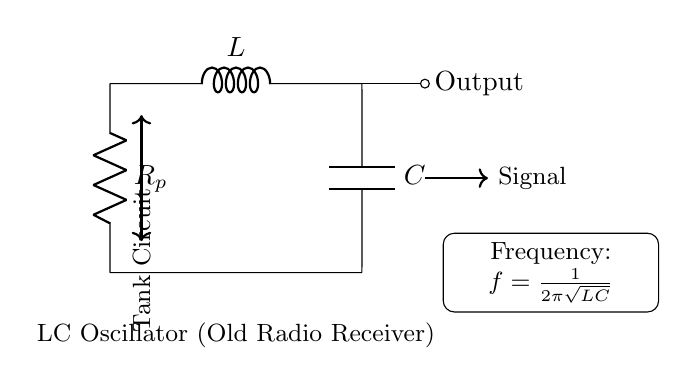What are the components used in the circuit? The circuit contains three components: an inductor (L), a capacitor (C), and a resistor (R_p). These can be identified by their labels in the diagram.
Answer: L, C, R_p What is the function of the tank circuit? The tank circuit, formed by the inductor and capacitor in parallel, is responsible for the oscillation, allowing the circuit to store and exchange energy between the inductor and capacitor, creating an oscillating signal.
Answer: Oscillation What does the output denote in the circuit diagram? The output is the point from which the signal can be extracted from the tank circuit, typically connected to the next stage of a radio receiver. It denotes the signal generated by the oscillation of the circuit.
Answer: Signal What is the formula for frequency provided in the circuit? The formula displayed indicates that frequency (f) is calculated using the inductance (L) and capacitance (C) with the equation f = 1/(2π√(LC)), which tells us how the circuit oscillates at certain frequencies depending on these values.
Answer: f = 1/(2π√(LC)) What type of circuit is represented here? This is an LC oscillator circuit, specifically designed for generating oscillatory waves for use in radio receivers and other applications. It uses the properties of inductance and capacitance to create oscillations.
Answer: LC Oscillator 